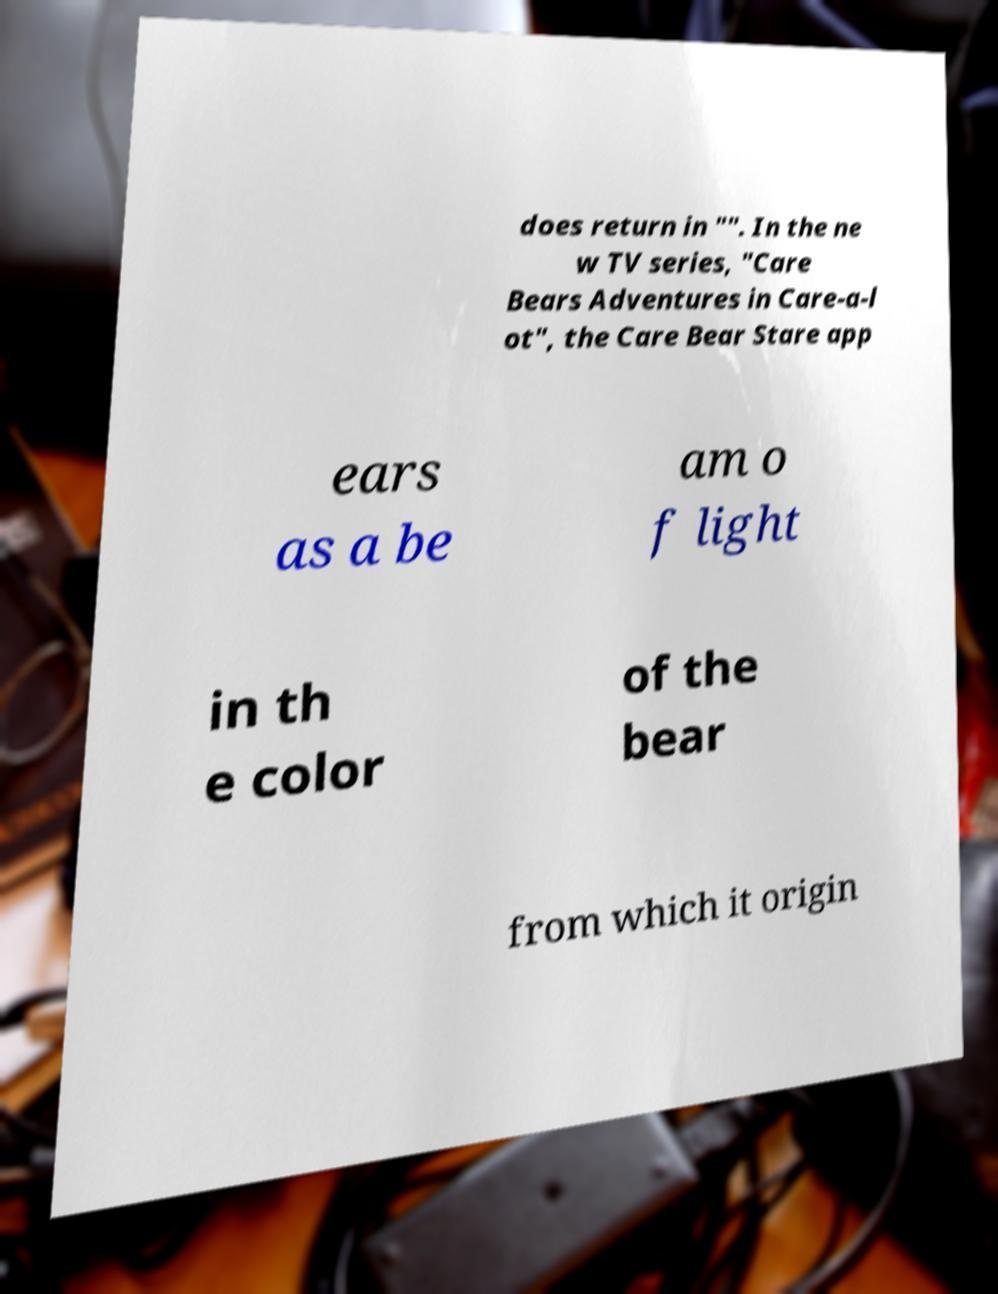Can you read and provide the text displayed in the image?This photo seems to have some interesting text. Can you extract and type it out for me? does return in "". In the ne w TV series, "Care Bears Adventures in Care-a-l ot", the Care Bear Stare app ears as a be am o f light in th e color of the bear from which it origin 